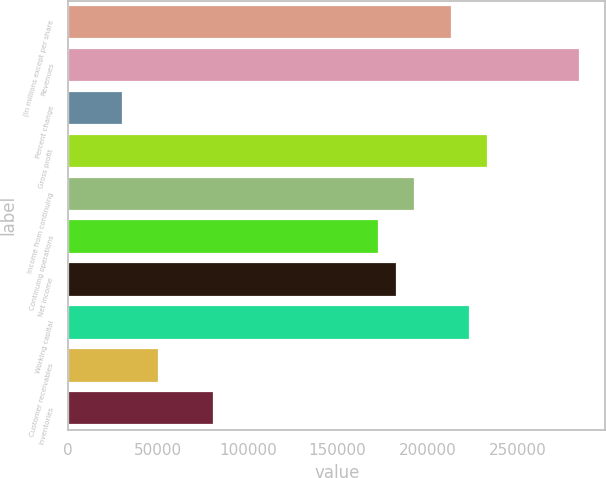<chart> <loc_0><loc_0><loc_500><loc_500><bar_chart><fcel>(In millions except per share<fcel>Revenues<fcel>Percent change<fcel>Gross profit<fcel>Income from continuing<fcel>Continuing operations<fcel>Net income<fcel>Working capital<fcel>Customer receivables<fcel>Inventories<nl><fcel>213576<fcel>284768<fcel>30511.1<fcel>233917<fcel>193236<fcel>172895<fcel>183065<fcel>223746<fcel>50851.6<fcel>81362.5<nl></chart> 